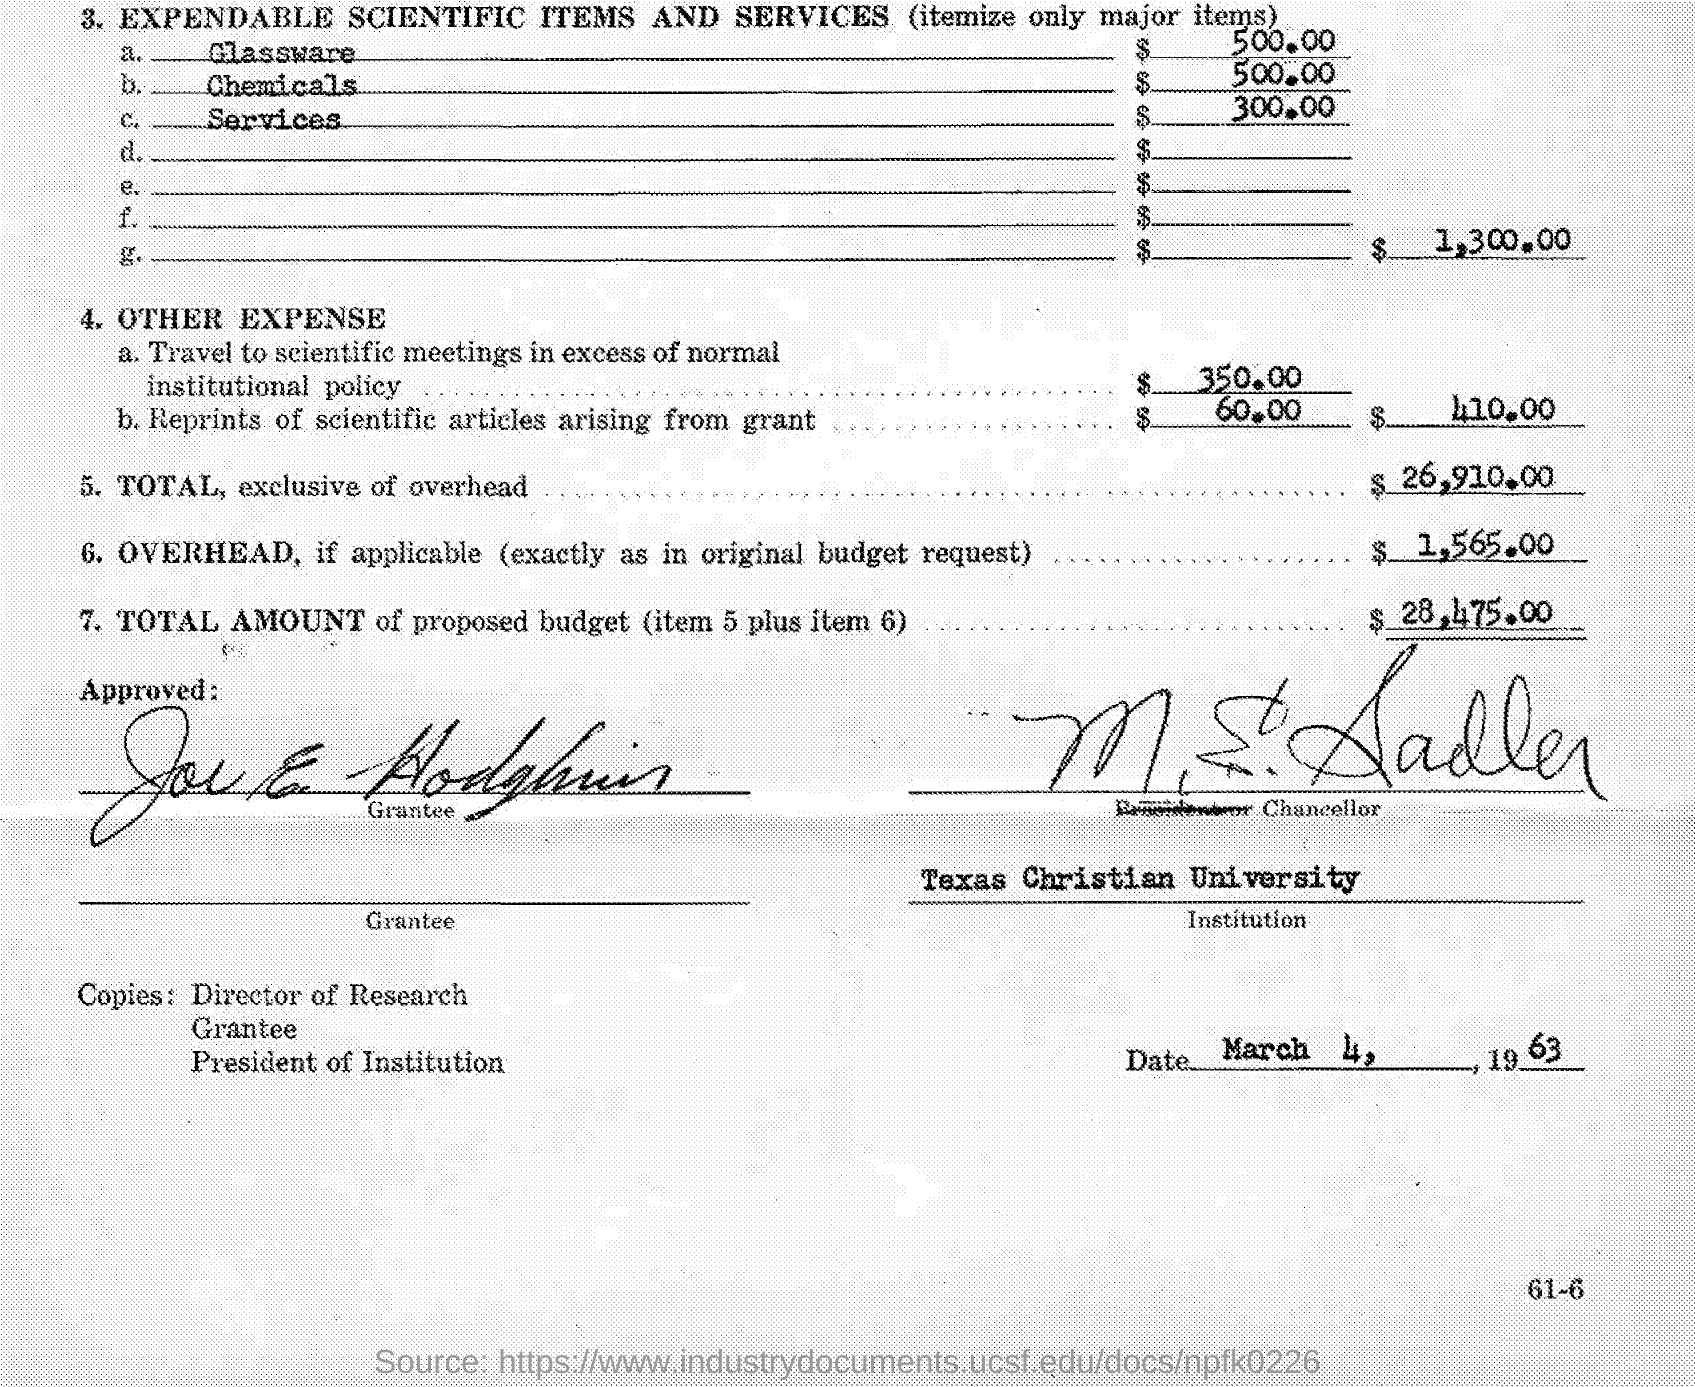Which institution is mentioned?
Ensure brevity in your answer.  Texas Christian University. When is the document dated?
Your answer should be compact. MARCH 4, 1963. 